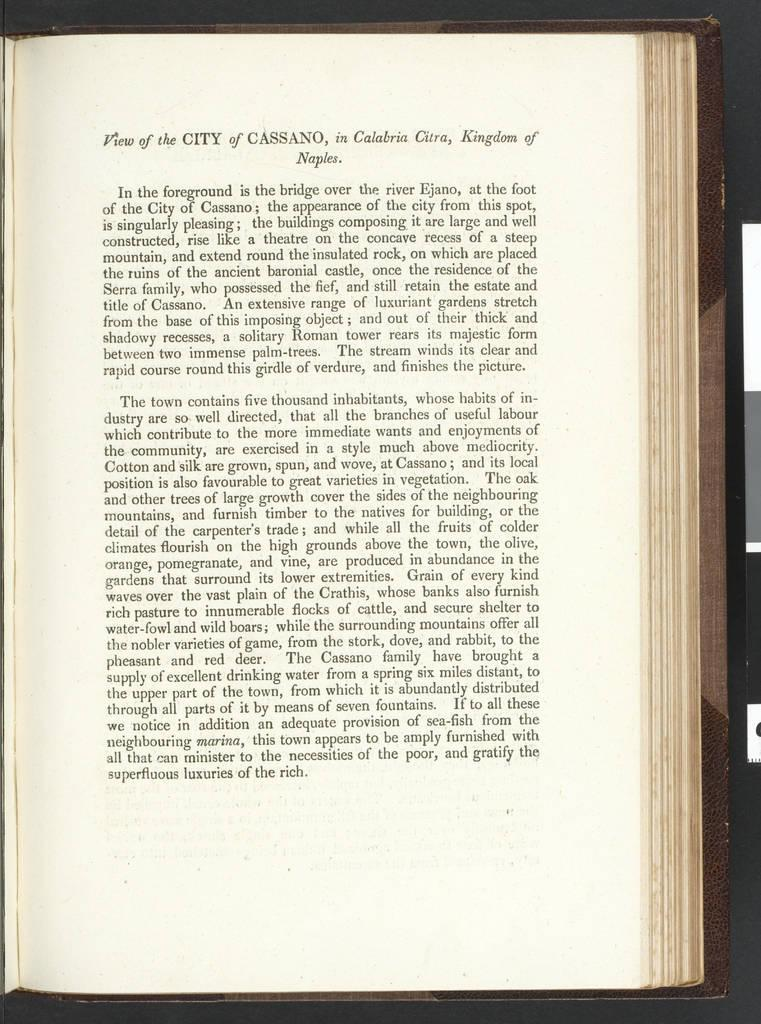What is present in the image related to reading or writing? There is a book and papers in the image. Can you describe the papers in the image? There are papers in the image, and there is writing on the paper. How many cats are sitting on the book in the image? There are no cats present in the image. What type of egg is visible in the image? There are no eggs present in the image. 